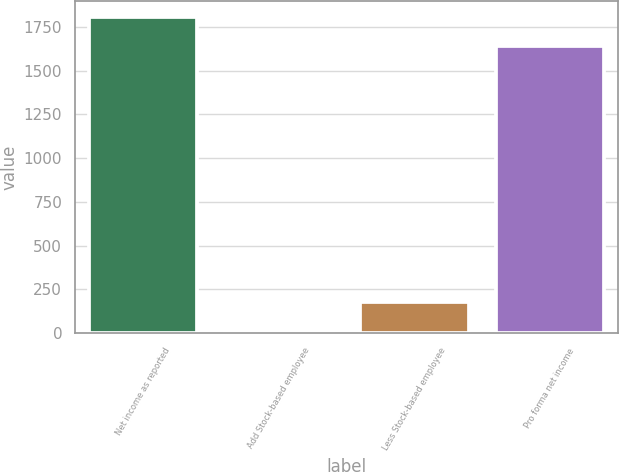Convert chart to OTSL. <chart><loc_0><loc_0><loc_500><loc_500><bar_chart><fcel>Net income as reported<fcel>Add Stock-based employee<fcel>Less Stock-based employee<fcel>Pro forma net income<nl><fcel>1806.86<fcel>11.6<fcel>179.86<fcel>1638.6<nl></chart> 